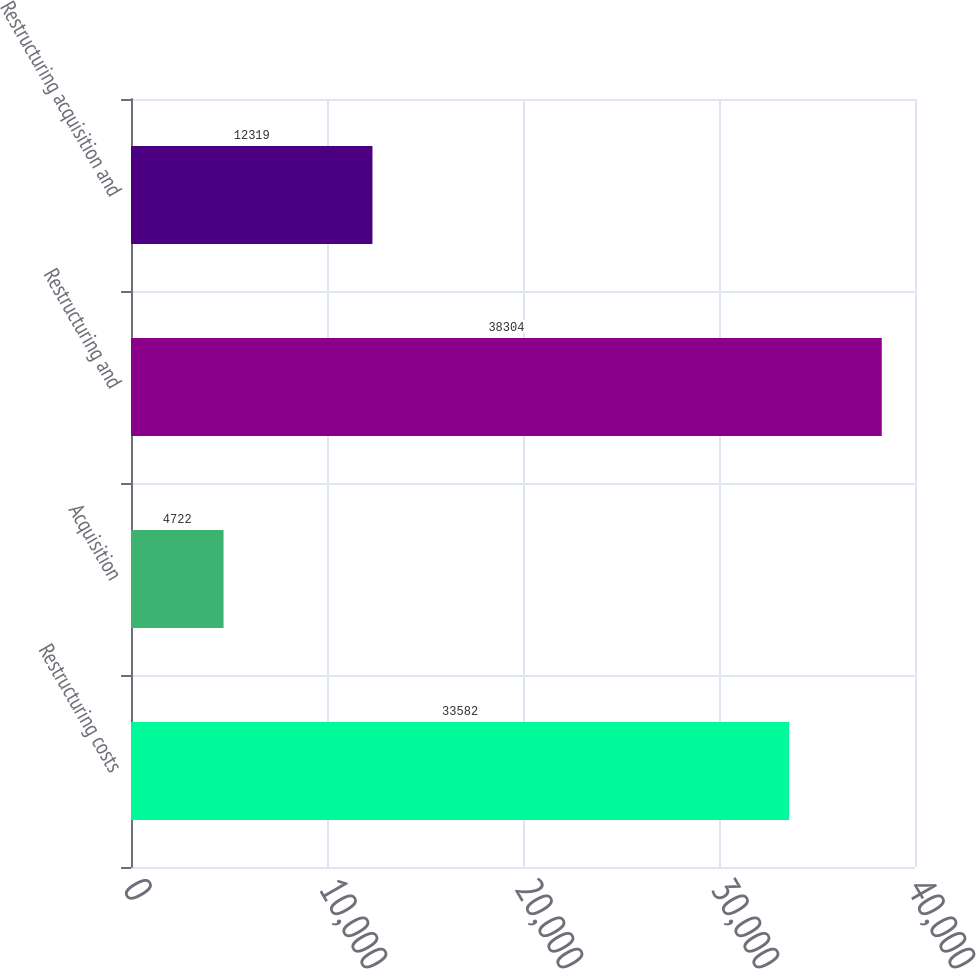<chart> <loc_0><loc_0><loc_500><loc_500><bar_chart><fcel>Restructuring costs<fcel>Acquisition<fcel>Restructuring and<fcel>Restructuring acquisition and<nl><fcel>33582<fcel>4722<fcel>38304<fcel>12319<nl></chart> 